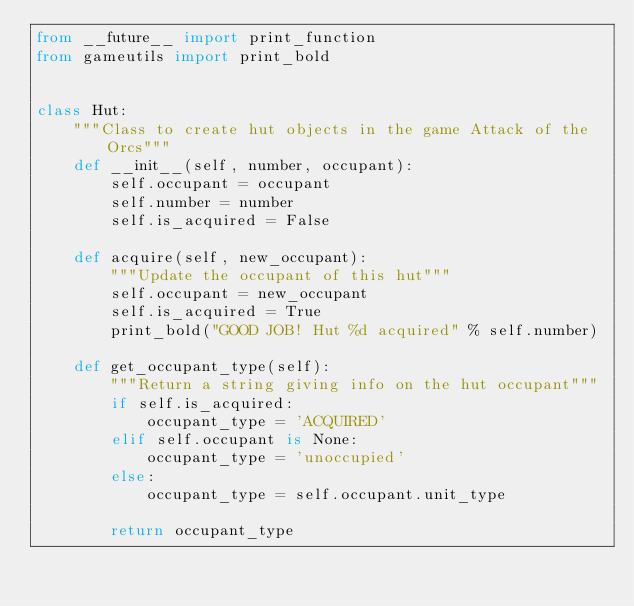Convert code to text. <code><loc_0><loc_0><loc_500><loc_500><_Python_>from __future__ import print_function
from gameutils import print_bold


class Hut:
    """Class to create hut objects in the game Attack of the Orcs"""
    def __init__(self, number, occupant):
        self.occupant = occupant
        self.number = number
        self.is_acquired = False

    def acquire(self, new_occupant):
        """Update the occupant of this hut"""
        self.occupant = new_occupant
        self.is_acquired = True
        print_bold("GOOD JOB! Hut %d acquired" % self.number)

    def get_occupant_type(self):
        """Return a string giving info on the hut occupant"""
        if self.is_acquired:
            occupant_type = 'ACQUIRED'
        elif self.occupant is None:
            occupant_type = 'unoccupied'
        else:
            occupant_type = self.occupant.unit_type

        return occupant_type

</code> 